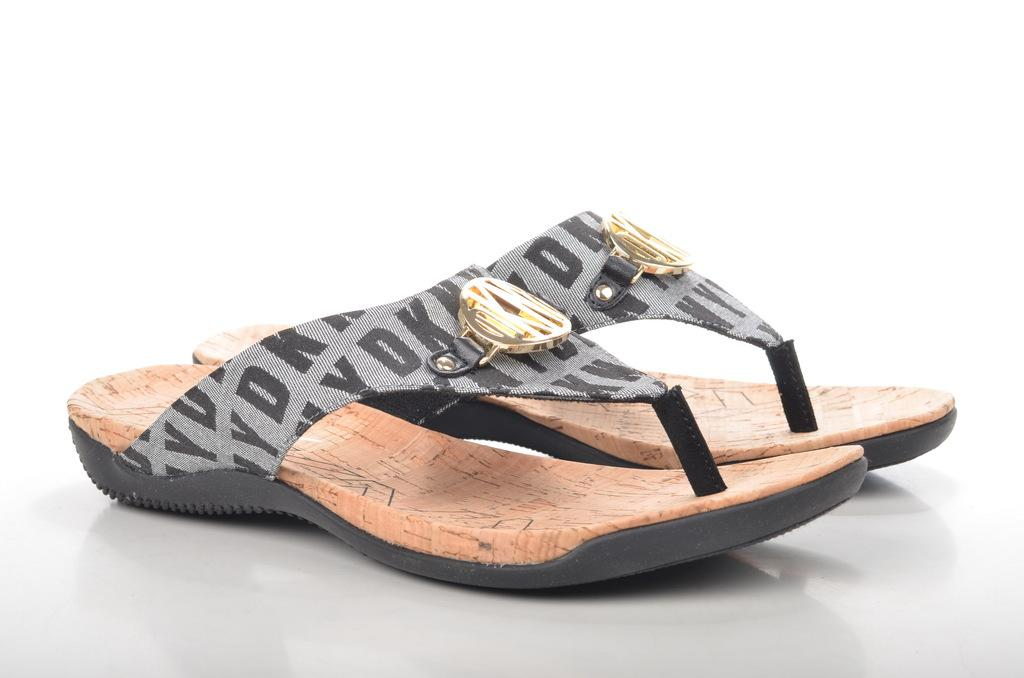What type of object is present in the image related to footwear? There is footwear in the image. What is the color of the floor in the image? The floor is white in color. Is the grass visible in the image? There is no grass present in the image; the floor is white. What type of straw is used to make the footwear in the image? There is no straw used in the footwear in the image, as the facts provided do not mention any specific materials. 